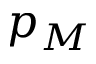<formula> <loc_0><loc_0><loc_500><loc_500>p _ { M }</formula> 